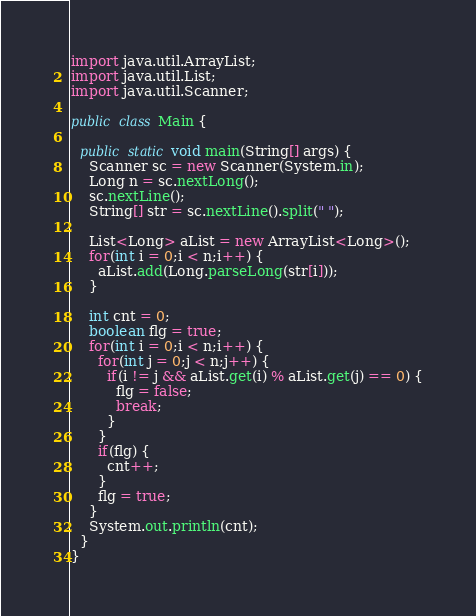Convert code to text. <code><loc_0><loc_0><loc_500><loc_500><_Java_>
import java.util.ArrayList;
import java.util.List;
import java.util.Scanner;

public class Main {

  public static void main(String[] args) {
    Scanner sc = new Scanner(System.in);
    Long n = sc.nextLong();
    sc.nextLine();
    String[] str = sc.nextLine().split(" ");

    List<Long> aList = new ArrayList<Long>();
    for(int i = 0;i < n;i++) {
      aList.add(Long.parseLong(str[i]));
    }

    int cnt = 0;
    boolean flg = true;
    for(int i = 0;i < n;i++) {
      for(int j = 0;j < n;j++) {
        if(i != j && aList.get(i) % aList.get(j) == 0) {
          flg = false;
          break;
        }
      }
      if(flg) {
        cnt++;
      }
      flg = true;
    }
    System.out.println(cnt);
  }
}
</code> 